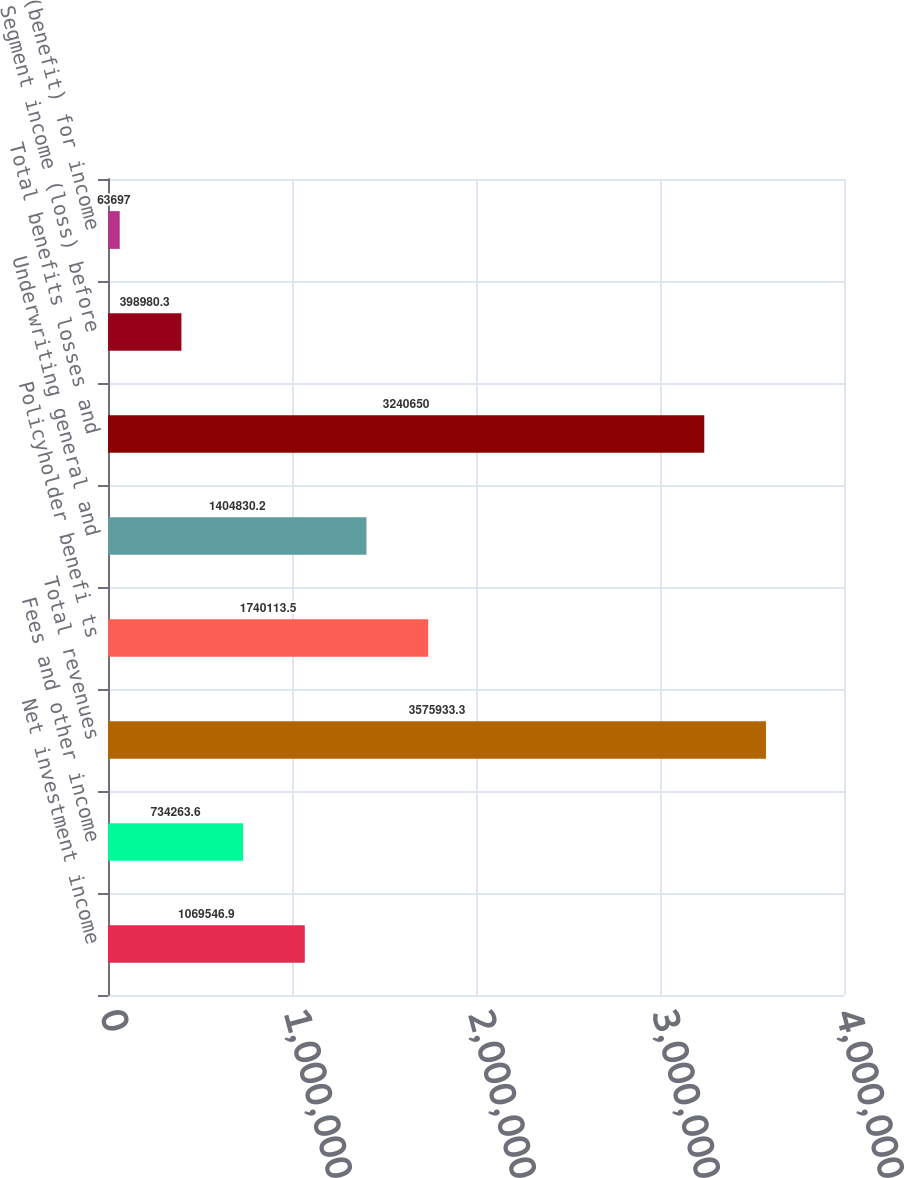<chart> <loc_0><loc_0><loc_500><loc_500><bar_chart><fcel>Net investment income<fcel>Fees and other income<fcel>Total revenues<fcel>Policyholder benefi ts<fcel>Underwriting general and<fcel>Total benefits losses and<fcel>Segment income (loss) before<fcel>Provision (benefit) for income<nl><fcel>1.06955e+06<fcel>734264<fcel>3.57593e+06<fcel>1.74011e+06<fcel>1.40483e+06<fcel>3.24065e+06<fcel>398980<fcel>63697<nl></chart> 